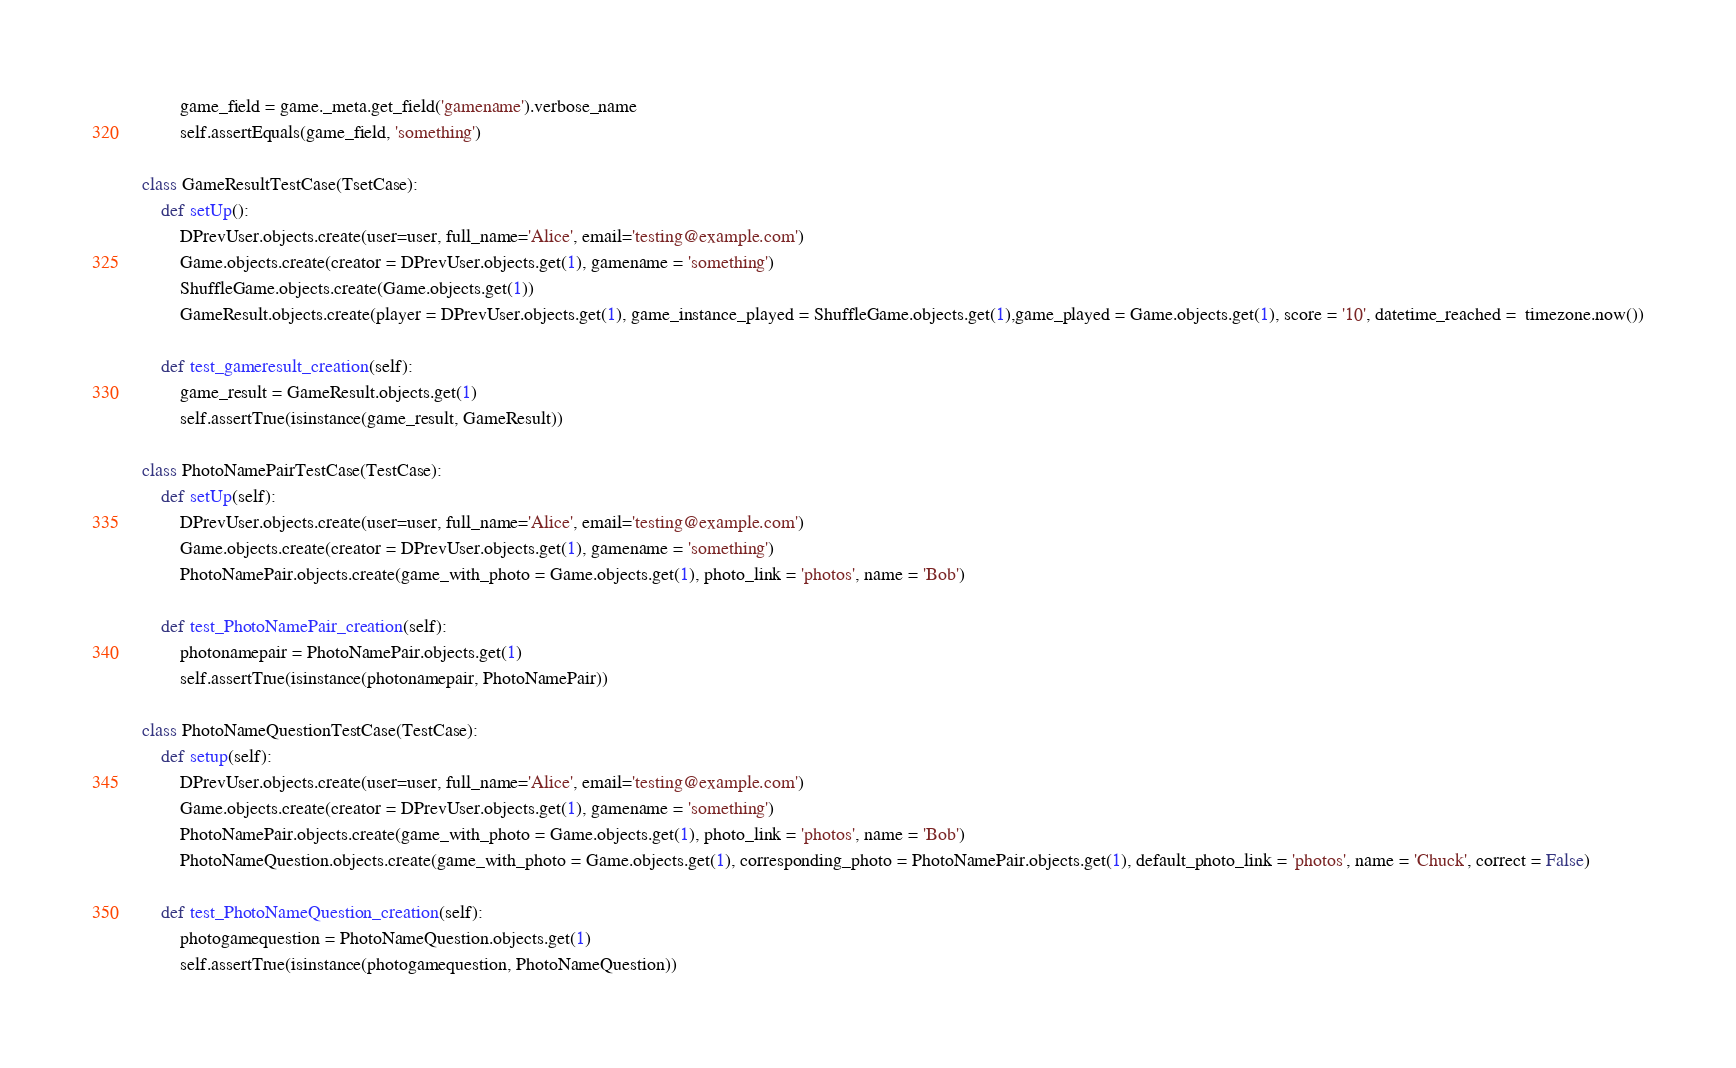Convert code to text. <code><loc_0><loc_0><loc_500><loc_500><_Python_>        game_field = game._meta.get_field('gamename').verbose_name
        self.assertEquals(game_field, 'something')
        
class GameResultTestCase(TsetCase):
    def setUp():
        DPrevUser.objects.create(user=user, full_name='Alice', email='testing@example.com')
        Game.objects.create(creator = DPrevUser.objects.get(1), gamename = 'something')
        ShuffleGame.objects.create(Game.objects.get(1))
        GameResult.objects.create(player = DPrevUser.objects.get(1), game_instance_played = ShuffleGame.objects.get(1),game_played = Game.objects.get(1), score = '10', datetime_reached =  timezone.now())

    def test_gameresult_creation(self):
        game_result = GameResult.objects.get(1)
        self.assertTrue(isinstance(game_result, GameResult))

class PhotoNamePairTestCase(TestCase):
    def setUp(self):
        DPrevUser.objects.create(user=user, full_name='Alice', email='testing@example.com')
        Game.objects.create(creator = DPrevUser.objects.get(1), gamename = 'something')
        PhotoNamePair.objects.create(game_with_photo = Game.objects.get(1), photo_link = 'photos', name = 'Bob')

    def test_PhotoNamePair_creation(self):
        photonamepair = PhotoNamePair.objects.get(1)
        self.assertTrue(isinstance(photonamepair, PhotoNamePair))

class PhotoNameQuestionTestCase(TestCase):
    def setup(self):
        DPrevUser.objects.create(user=user, full_name='Alice', email='testing@example.com')
        Game.objects.create(creator = DPrevUser.objects.get(1), gamename = 'something')
        PhotoNamePair.objects.create(game_with_photo = Game.objects.get(1), photo_link = 'photos', name = 'Bob')
        PhotoNameQuestion.objects.create(game_with_photo = Game.objects.get(1), corresponding_photo = PhotoNamePair.objects.get(1), default_photo_link = 'photos', name = 'Chuck', correct = False)

    def test_PhotoNameQuestion_creation(self):
        photogamequestion = PhotoNameQuestion.objects.get(1)
        self.assertTrue(isinstance(photogamequestion, PhotoNameQuestion))


</code> 